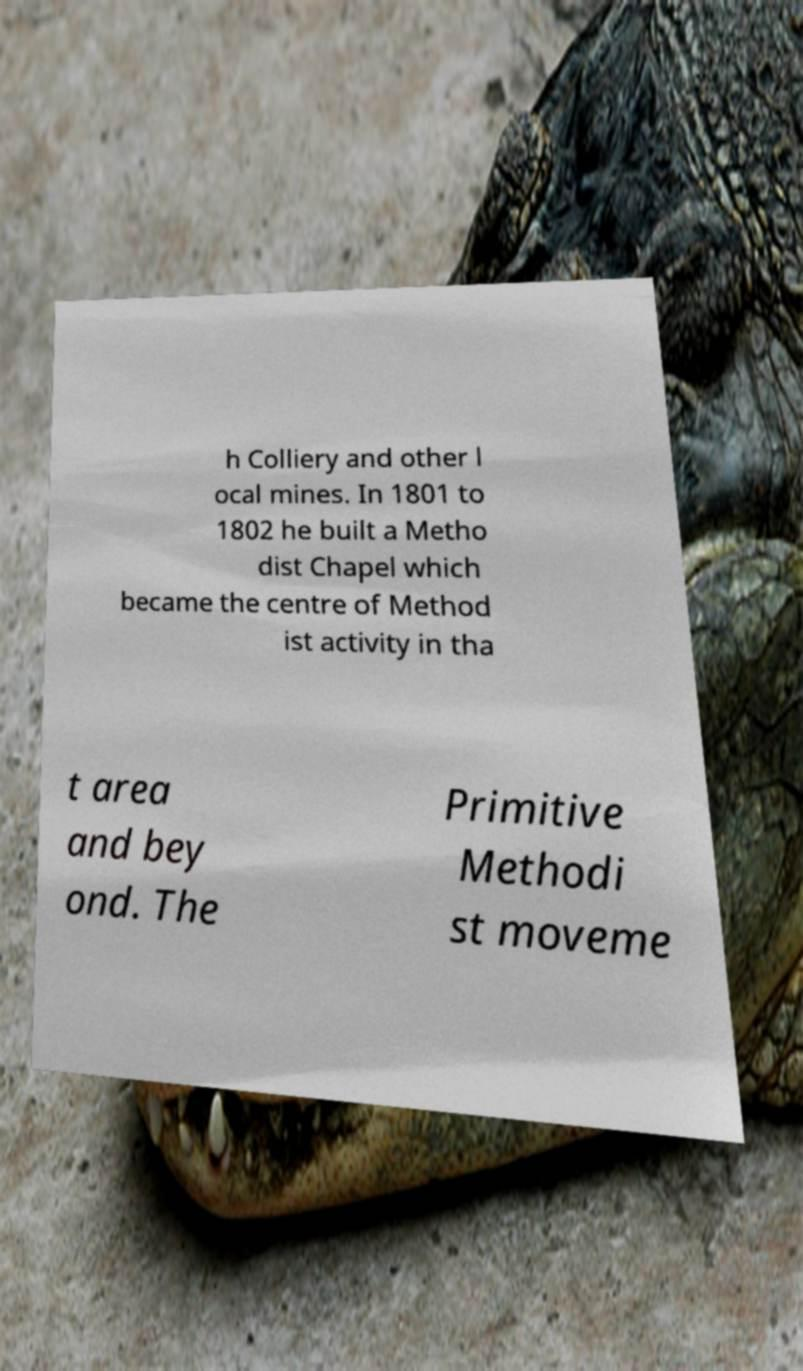For documentation purposes, I need the text within this image transcribed. Could you provide that? h Colliery and other l ocal mines. In 1801 to 1802 he built a Metho dist Chapel which became the centre of Method ist activity in tha t area and bey ond. The Primitive Methodi st moveme 